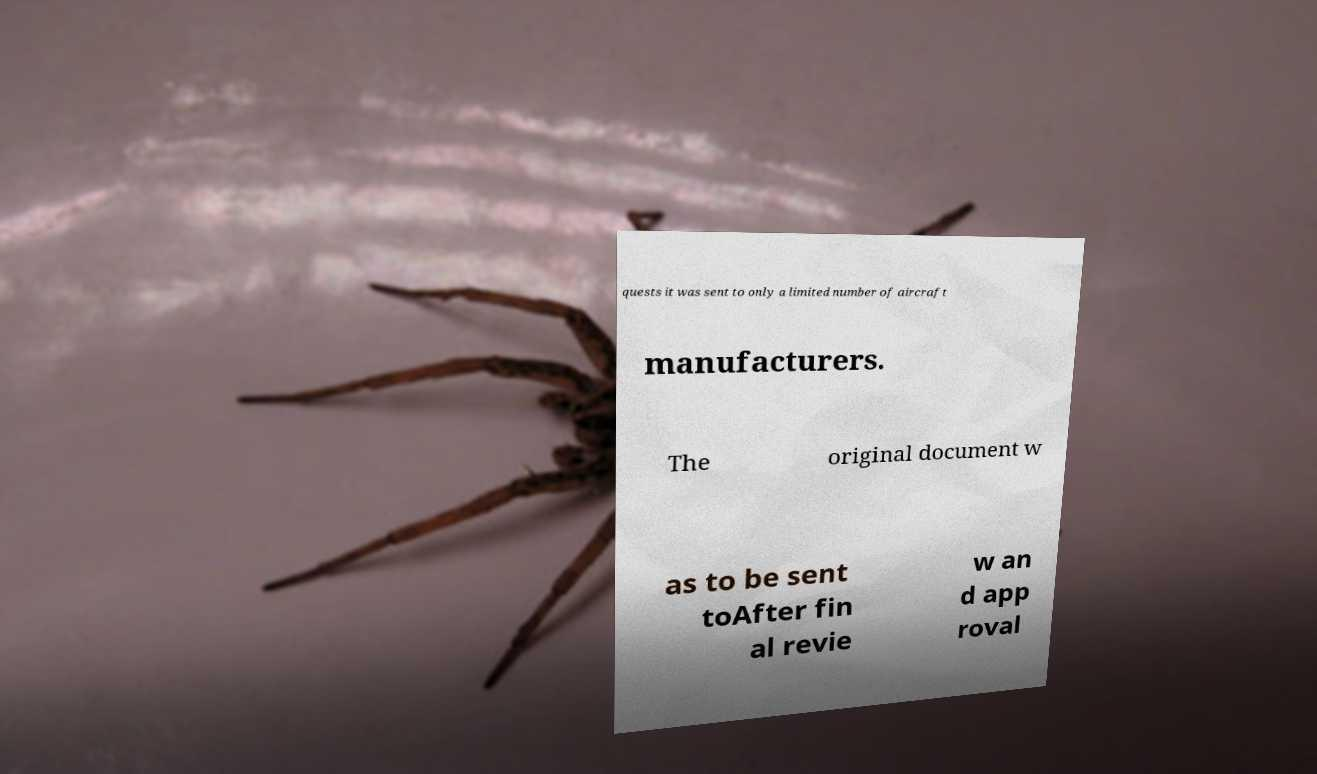Could you assist in decoding the text presented in this image and type it out clearly? quests it was sent to only a limited number of aircraft manufacturers. The original document w as to be sent toAfter fin al revie w an d app roval 